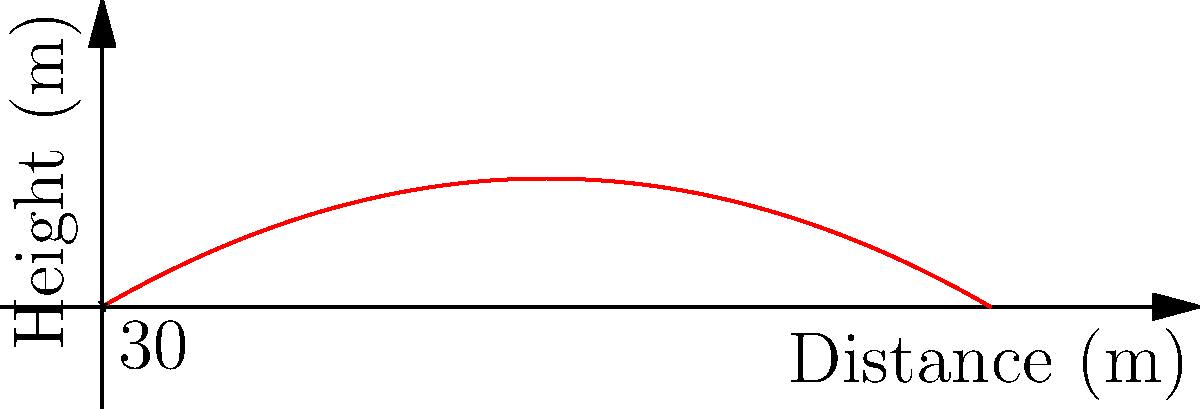A police officer wants to understand the trajectory of a bullet fired from a standard-issue handgun. The bullet is fired with an initial velocity of 300 m/s at an angle of 30° above the horizontal. Assuming no air resistance, what is the maximum height reached by the bullet? To find the maximum height of the bullet's trajectory, we'll follow these steps:

1) The vertical component of the initial velocity is given by:
   $v_{0y} = v_0 \sin(\theta) = 300 \cdot \sin(30°) = 150$ m/s

2) The time to reach the maximum height is when the vertical velocity becomes zero:
   $t_{max} = \frac{v_{0y}}{g}$, where $g$ is the acceleration due to gravity (9.8 m/s²)
   
   $t_{max} = \frac{150}{9.8} \approx 15.31$ seconds

3) The maximum height can be calculated using the equation:
   $h_{max} = v_{0y} \cdot t_{max} - \frac{1}{2}g \cdot t_{max}^2$

4) Substituting the values:
   $h_{max} = 150 \cdot 15.31 - \frac{1}{2} \cdot 9.8 \cdot 15.31^2$
   
   $h_{max} = 2296.5 - 1148.25 = 1148.25$ meters

Therefore, the maximum height reached by the bullet is approximately 1148.25 meters.
Answer: 1148.25 meters 